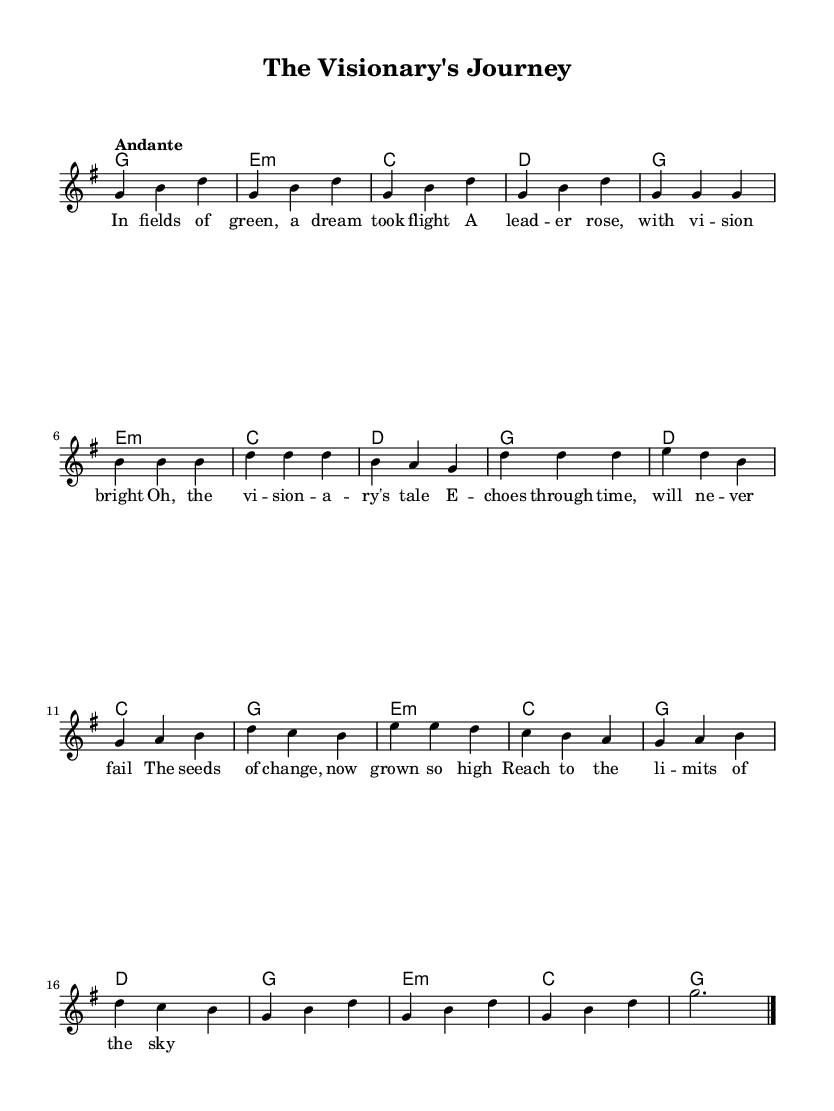What is the key signature of this music? The key signature is G major, which has one sharp (F#). This is indicated at the beginning of the score after the clef symbol.
Answer: G major What is the time signature of the piece? The time signature is 3/4, as shown at the beginning of the score. This means there are three beats in each measure, and the quarter note receives one beat.
Answer: 3/4 What is the tempo marking for this piece? The tempo marking is "Andante," which generally indicates a moderate and walking pace. This is noted above the staff.
Answer: Andante How many measures are in the music? The score contains a total of 25 measures. This can be determined by counting the measure lines throughout the score, including the intro, verses, chorus, bridge, and outro.
Answer: 25 What is the main theme of the lyrics? The main theme of the lyrics revolves around visionary leadership and the impact it has on change and dreams, as conveyed through the poetic imagery. The lyrics narrate the tale of a leader’s dream taking flight, illustrating the profound effect of their vision.
Answer: Visionary leadership What chords accompany the verse section? The chords accompanying the verse section are G, E minor, C, and D. These are indicated in the chord changes below the melody. You can see them consistently applied throughout the verse.
Answer: G, E minor, C, D What is the overall mood of the composition? The overall mood of the composition is reflective and hopeful, indicated by the use of a 3/4 time signature and an Andante tempo. The lyrical themes and melodic movement further support this reflective quality, evoking a sense of nostalgia and aspiration.
Answer: Reflective and hopeful 